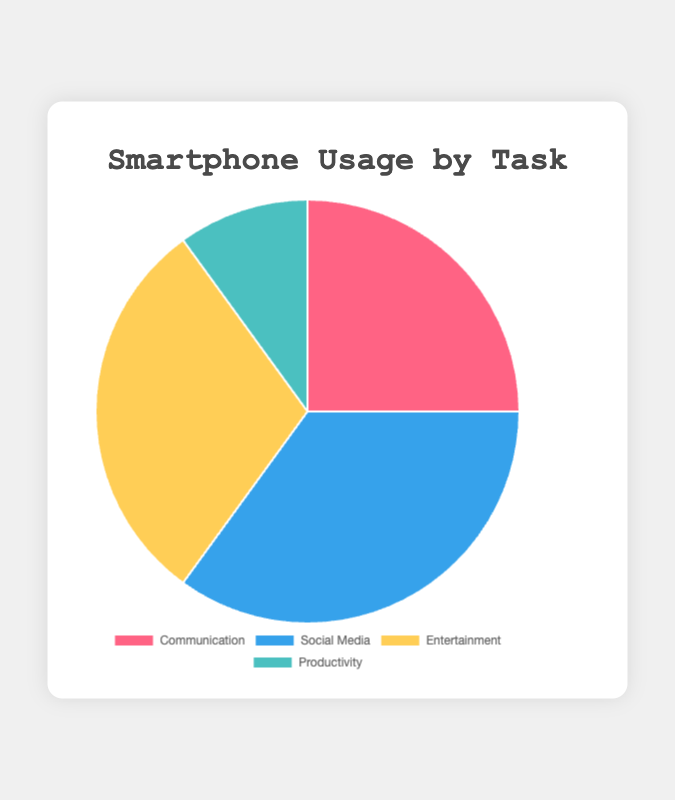Which task has the highest usage percentage? By looking at the pie chart, we can see that the largest slice corresponds to Social Media, which is indicated as having the highest usage percentage.
Answer: Social Media Which task has the lowest usage percentage? Observing the pie chart, the smallest slice is for Productivity, indicating it has the lowest usage percentage.
Answer: Productivity What is the total percentage of usage for Communication and Entertainment tasks combined? The percentage for Communication is 25% and for Entertainment is 30%. Adding these together, 25% + 30% = 55%.
Answer: 55% By how much does the usage percentage of Social Media exceed that of Productivity? The usage percentage for Social Media is 35%, and for Productivity, it is 10%. The difference is 35% - 10% = 25%.
Answer: 25% What fraction of the total usage is represented by the Entertainment task? The percentage for Entertainment is 30%. This can be converted to a fraction by dividing by 100: 30/100, which reduces to 3/10.
Answer: 3/10 Are the combined usage percentages of Communication and Productivity greater or less than the usage percentage of Social Media? Adding the percentages for Communication (25%) and Productivity (10%) gives 25% + 10% = 35%. Since the percentage for Social Media is 35%, they are equal.
Answer: Equal Which task's usage percentage is closest to the average usage percentage of all tasks? The average usage percentage is calculated by summing all percentages: 25% (Communication) + 35% (Social Media) + 30% (Entertainment) + 10% (Productivity) = 100%, and then dividing by 4 tasks, 100% ÷ 4 = 25%. The usage percentage closest to this average is Communication, which is exactly 25%.
Answer: Communication What color represents the Social Media slice in the chart? By referring to the color legend in the pie chart, Social Media is indicated in blue.
Answer: Blue 